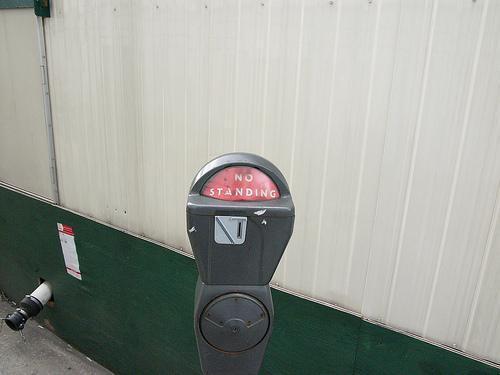How many parking meters are in the photo?
Give a very brief answer. 1. How many of the white letters in the parking meter are consonants?
Give a very brief answer. 7. 